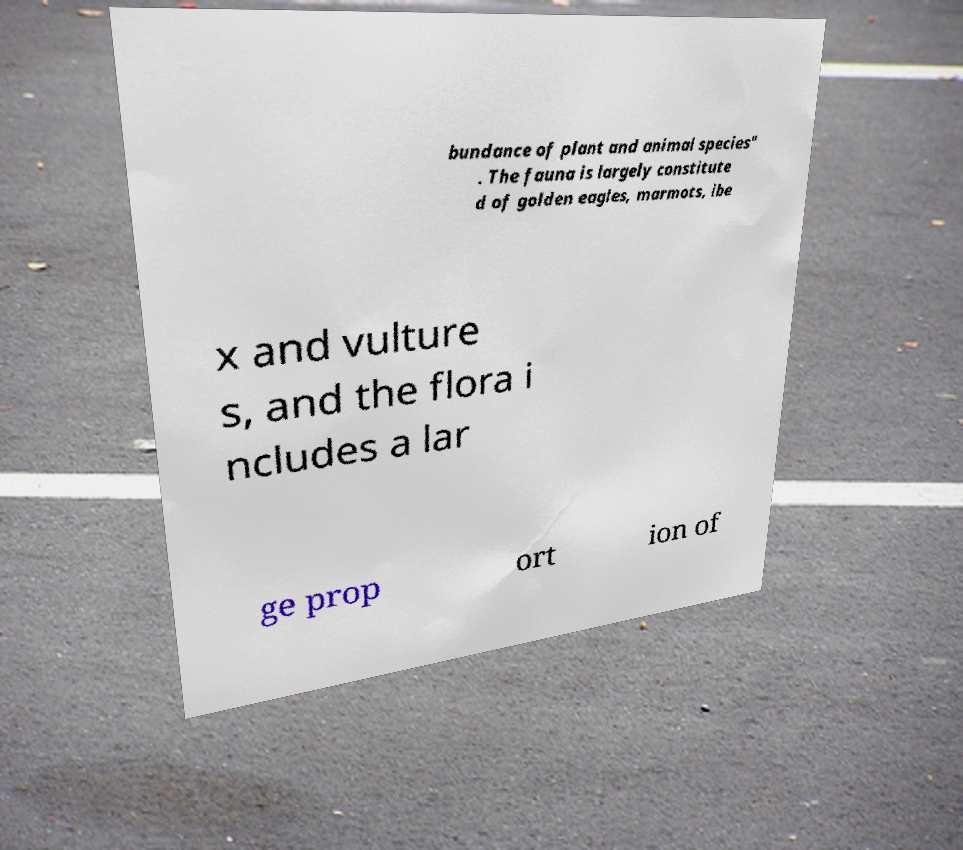Could you assist in decoding the text presented in this image and type it out clearly? bundance of plant and animal species" . The fauna is largely constitute d of golden eagles, marmots, ibe x and vulture s, and the flora i ncludes a lar ge prop ort ion of 